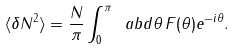Convert formula to latex. <formula><loc_0><loc_0><loc_500><loc_500>\langle \delta N ^ { 2 } \rangle = \frac { N } { \pi } \int _ { 0 } ^ { \pi } \ a b d \theta \, F ( \theta ) e ^ { - i \theta } .</formula> 